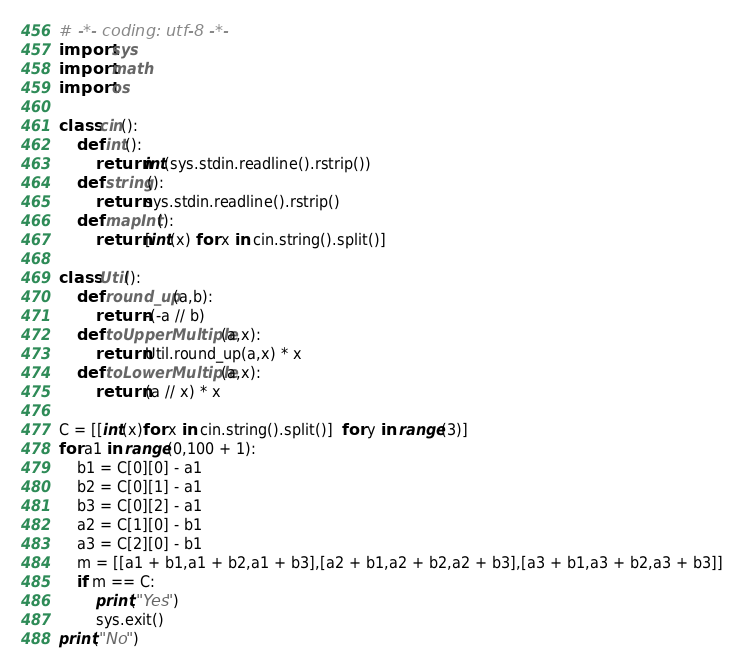Convert code to text. <code><loc_0><loc_0><loc_500><loc_500><_Python_># -*- coding: utf-8 -*-
import sys
import math
import os

class cin():
    def int():
        return int(sys.stdin.readline().rstrip())
    def string():
        return sys.stdin.readline().rstrip()
    def mapInt():
        return [int(x) for x in cin.string().split()]

class Util():
    def round_up(a,b):
        return -(-a // b)
    def toUpperMultiple(a,x):
        return Util.round_up(a,x) * x
    def toLowerMultiple(a,x):
        return (a // x) * x

C = [[int(x)for x in cin.string().split()]  for y in range(3)]
for a1 in range(0,100 + 1):
    b1 = C[0][0] - a1
    b2 = C[0][1] - a1
    b3 = C[0][2] - a1
    a2 = C[1][0] - b1
    a3 = C[2][0] - b1
    m = [[a1 + b1,a1 + b2,a1 + b3],[a2 + b1,a2 + b2,a2 + b3],[a3 + b1,a3 + b2,a3 + b3]]
    if m == C:
        print("Yes")
        sys.exit()
print("No")</code> 